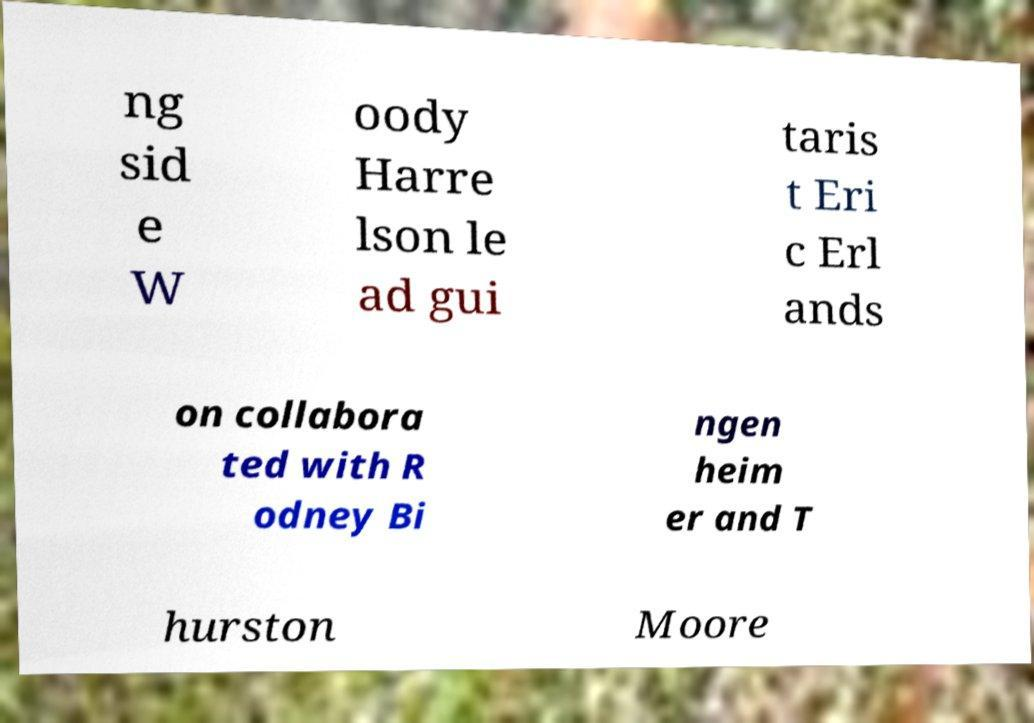Please identify and transcribe the text found in this image. ng sid e W oody Harre lson le ad gui taris t Eri c Erl ands on collabora ted with R odney Bi ngen heim er and T hurston Moore 